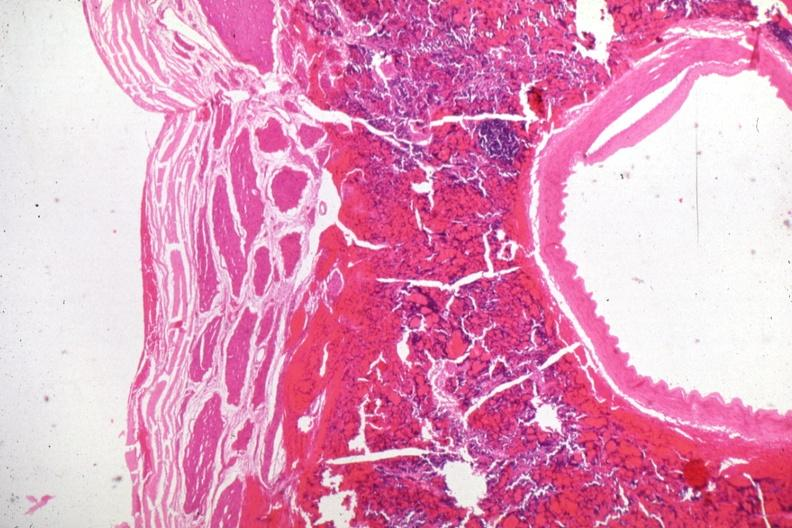s endocrine present?
Answer the question using a single word or phrase. Yes 